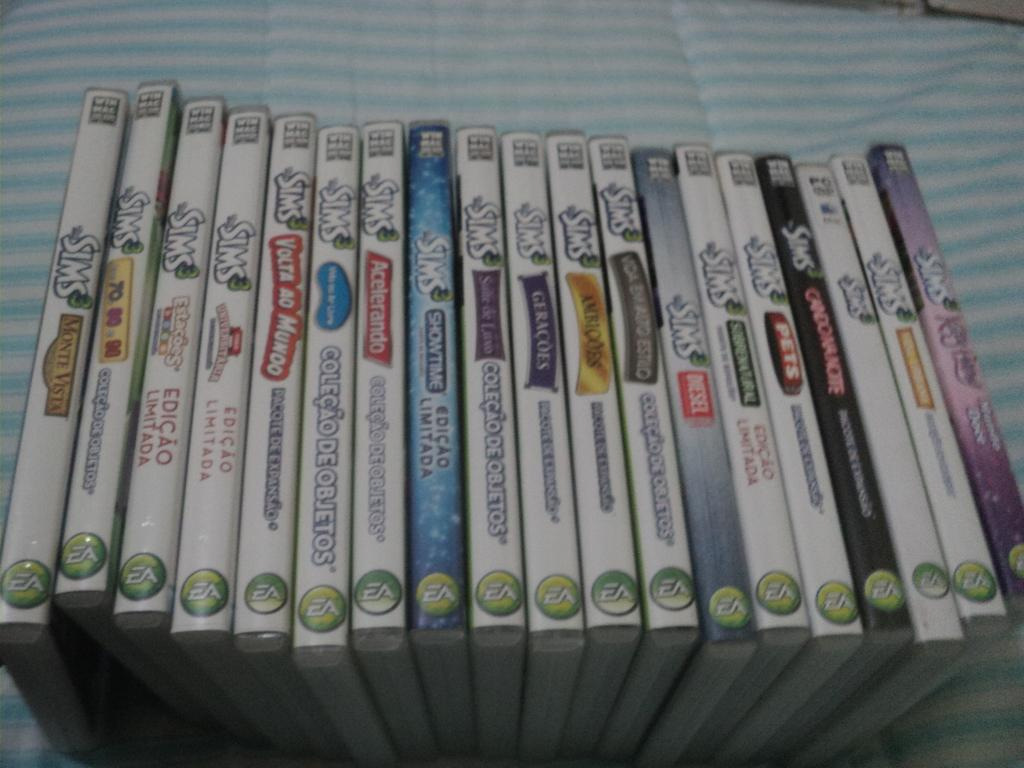What objects are present in the image? There are boxes in the image. What is the color of the surface on which the boxes are placed? The surface is blue and white in color. Are there any markings or text on the boxes? Yes, there is writing on the boxes. Can you see a kitten playing with scissors during the rainstorm in the image? There is no kitten, scissors, or rainstorm present in the image. 